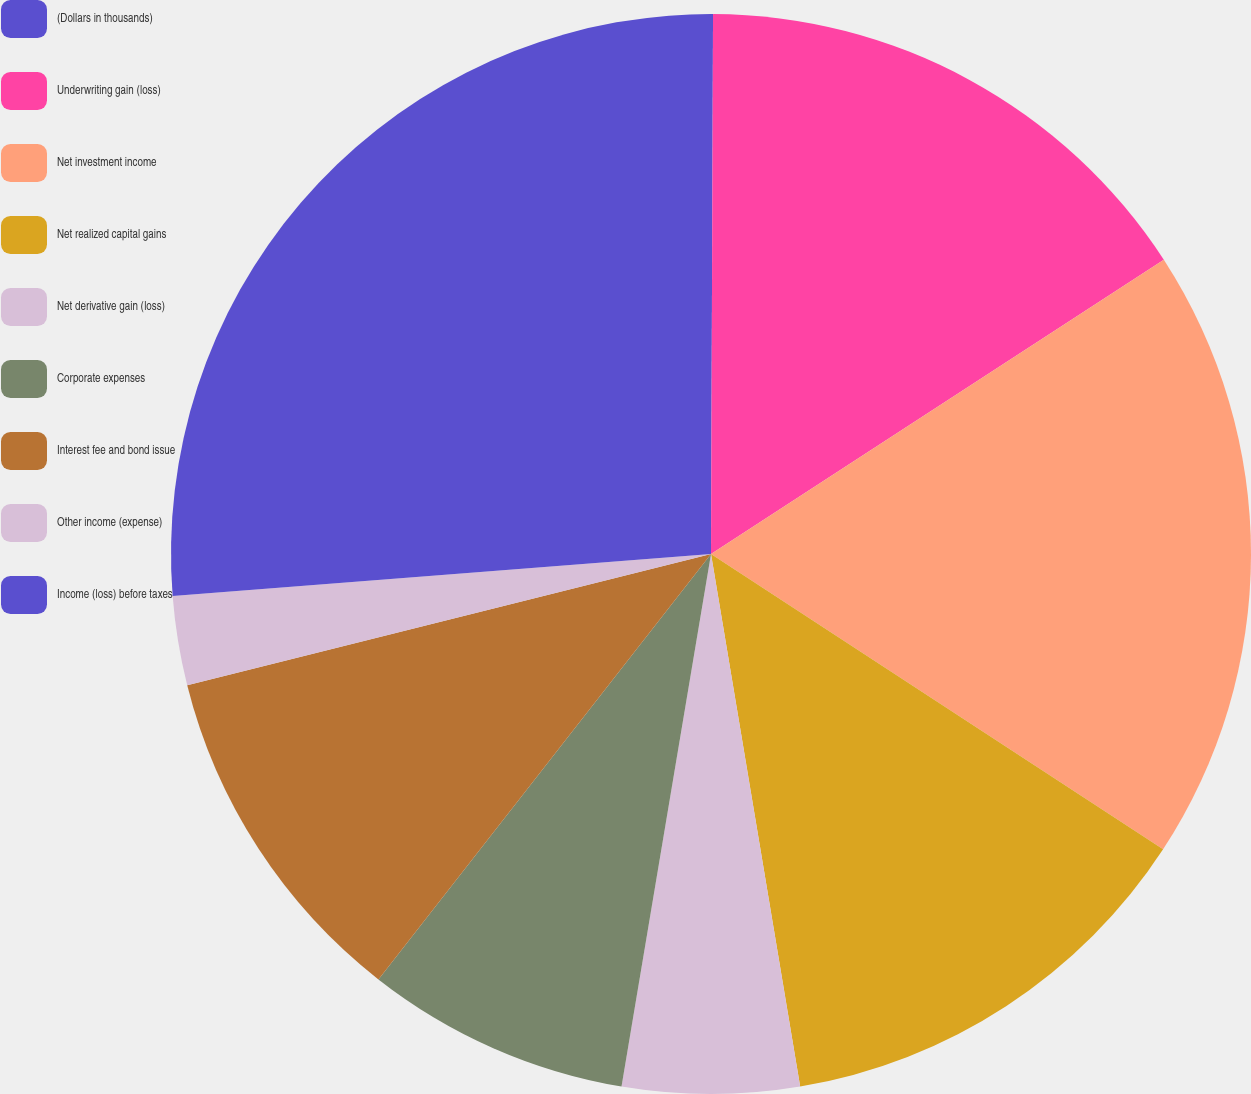<chart> <loc_0><loc_0><loc_500><loc_500><pie_chart><fcel>(Dollars in thousands)<fcel>Underwriting gain (loss)<fcel>Net investment income<fcel>Net realized capital gains<fcel>Net derivative gain (loss)<fcel>Corporate expenses<fcel>Interest fee and bond issue<fcel>Other income (expense)<fcel>Income (loss) before taxes<nl><fcel>0.06%<fcel>15.77%<fcel>18.38%<fcel>13.15%<fcel>5.29%<fcel>7.91%<fcel>10.53%<fcel>2.67%<fcel>26.24%<nl></chart> 